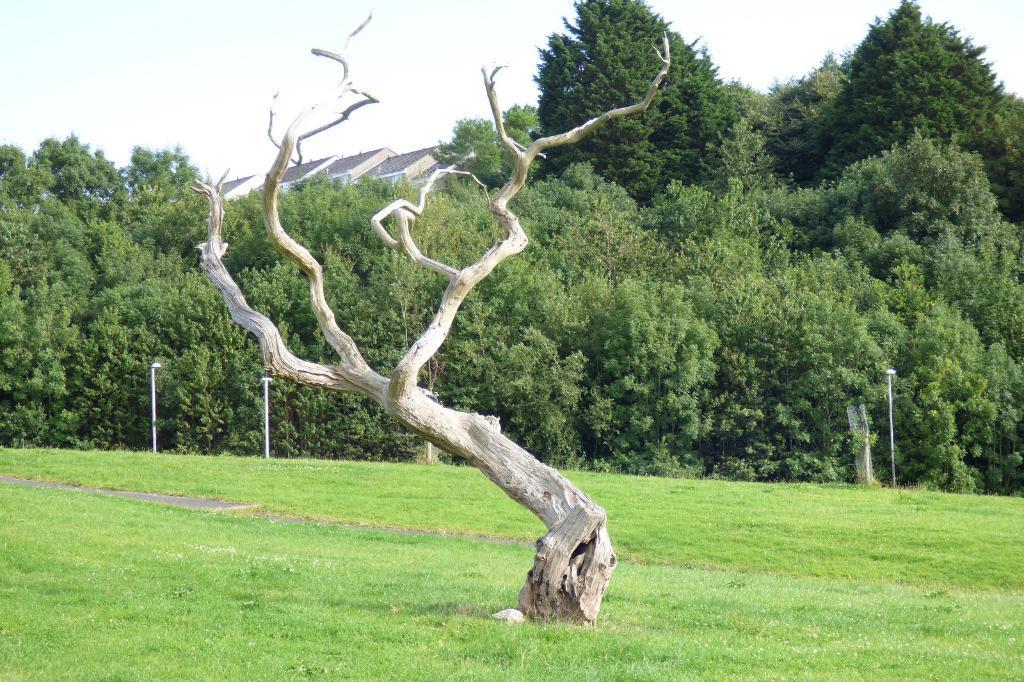Could you give a brief overview of what you see in this image? In this picture we can see the grass, poles, trees, roof and in the background we can see the sky. 